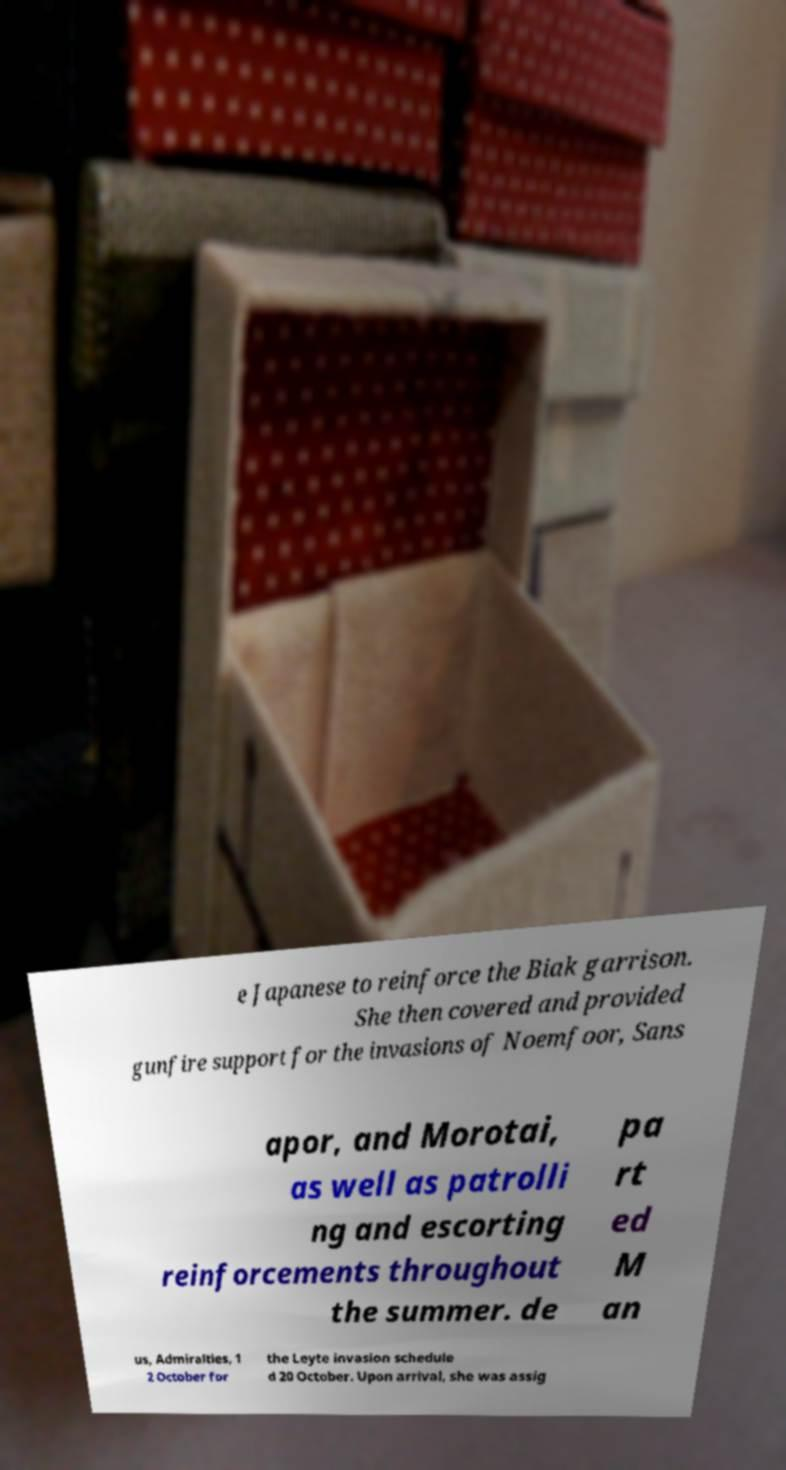For documentation purposes, I need the text within this image transcribed. Could you provide that? e Japanese to reinforce the Biak garrison. She then covered and provided gunfire support for the invasions of Noemfoor, Sans apor, and Morotai, as well as patrolli ng and escorting reinforcements throughout the summer. de pa rt ed M an us, Admiralties, 1 2 October for the Leyte invasion schedule d 20 October. Upon arrival, she was assig 